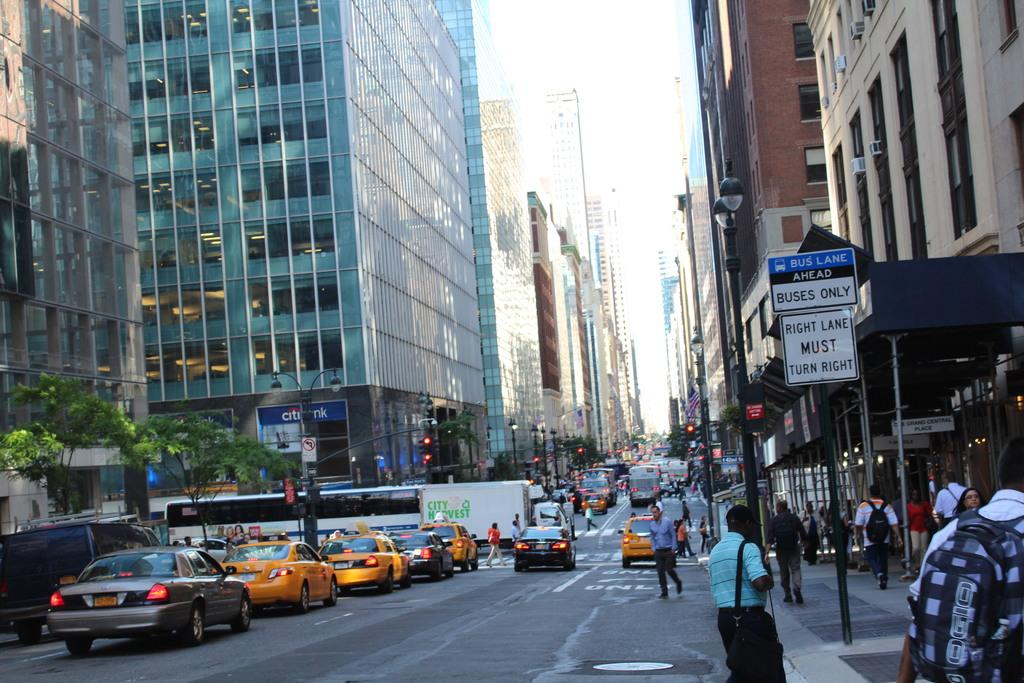What is the main feature of the image? There is a road in the image. What are the people doing on the road? There are people walking on the road. What else can be seen on the road? There are vehicles on the road. What can be seen in the background of the image? There are boards, a building, and the sky visible in the background of the image. What type of surprise can be seen in the image? There is no surprise present in the image; it features a road with people walking and vehicles, along with background elements. 